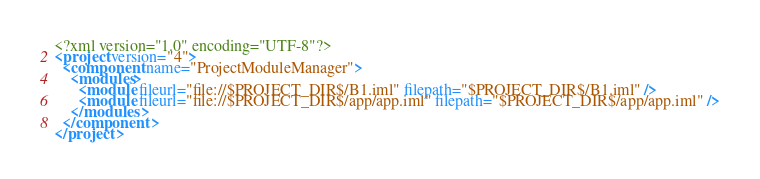<code> <loc_0><loc_0><loc_500><loc_500><_XML_><?xml version="1.0" encoding="UTF-8"?>
<project version="4">
  <component name="ProjectModuleManager">
    <modules>
      <module fileurl="file://$PROJECT_DIR$/B1.iml" filepath="$PROJECT_DIR$/B1.iml" />
      <module fileurl="file://$PROJECT_DIR$/app/app.iml" filepath="$PROJECT_DIR$/app/app.iml" />
    </modules>
  </component>
</project></code> 